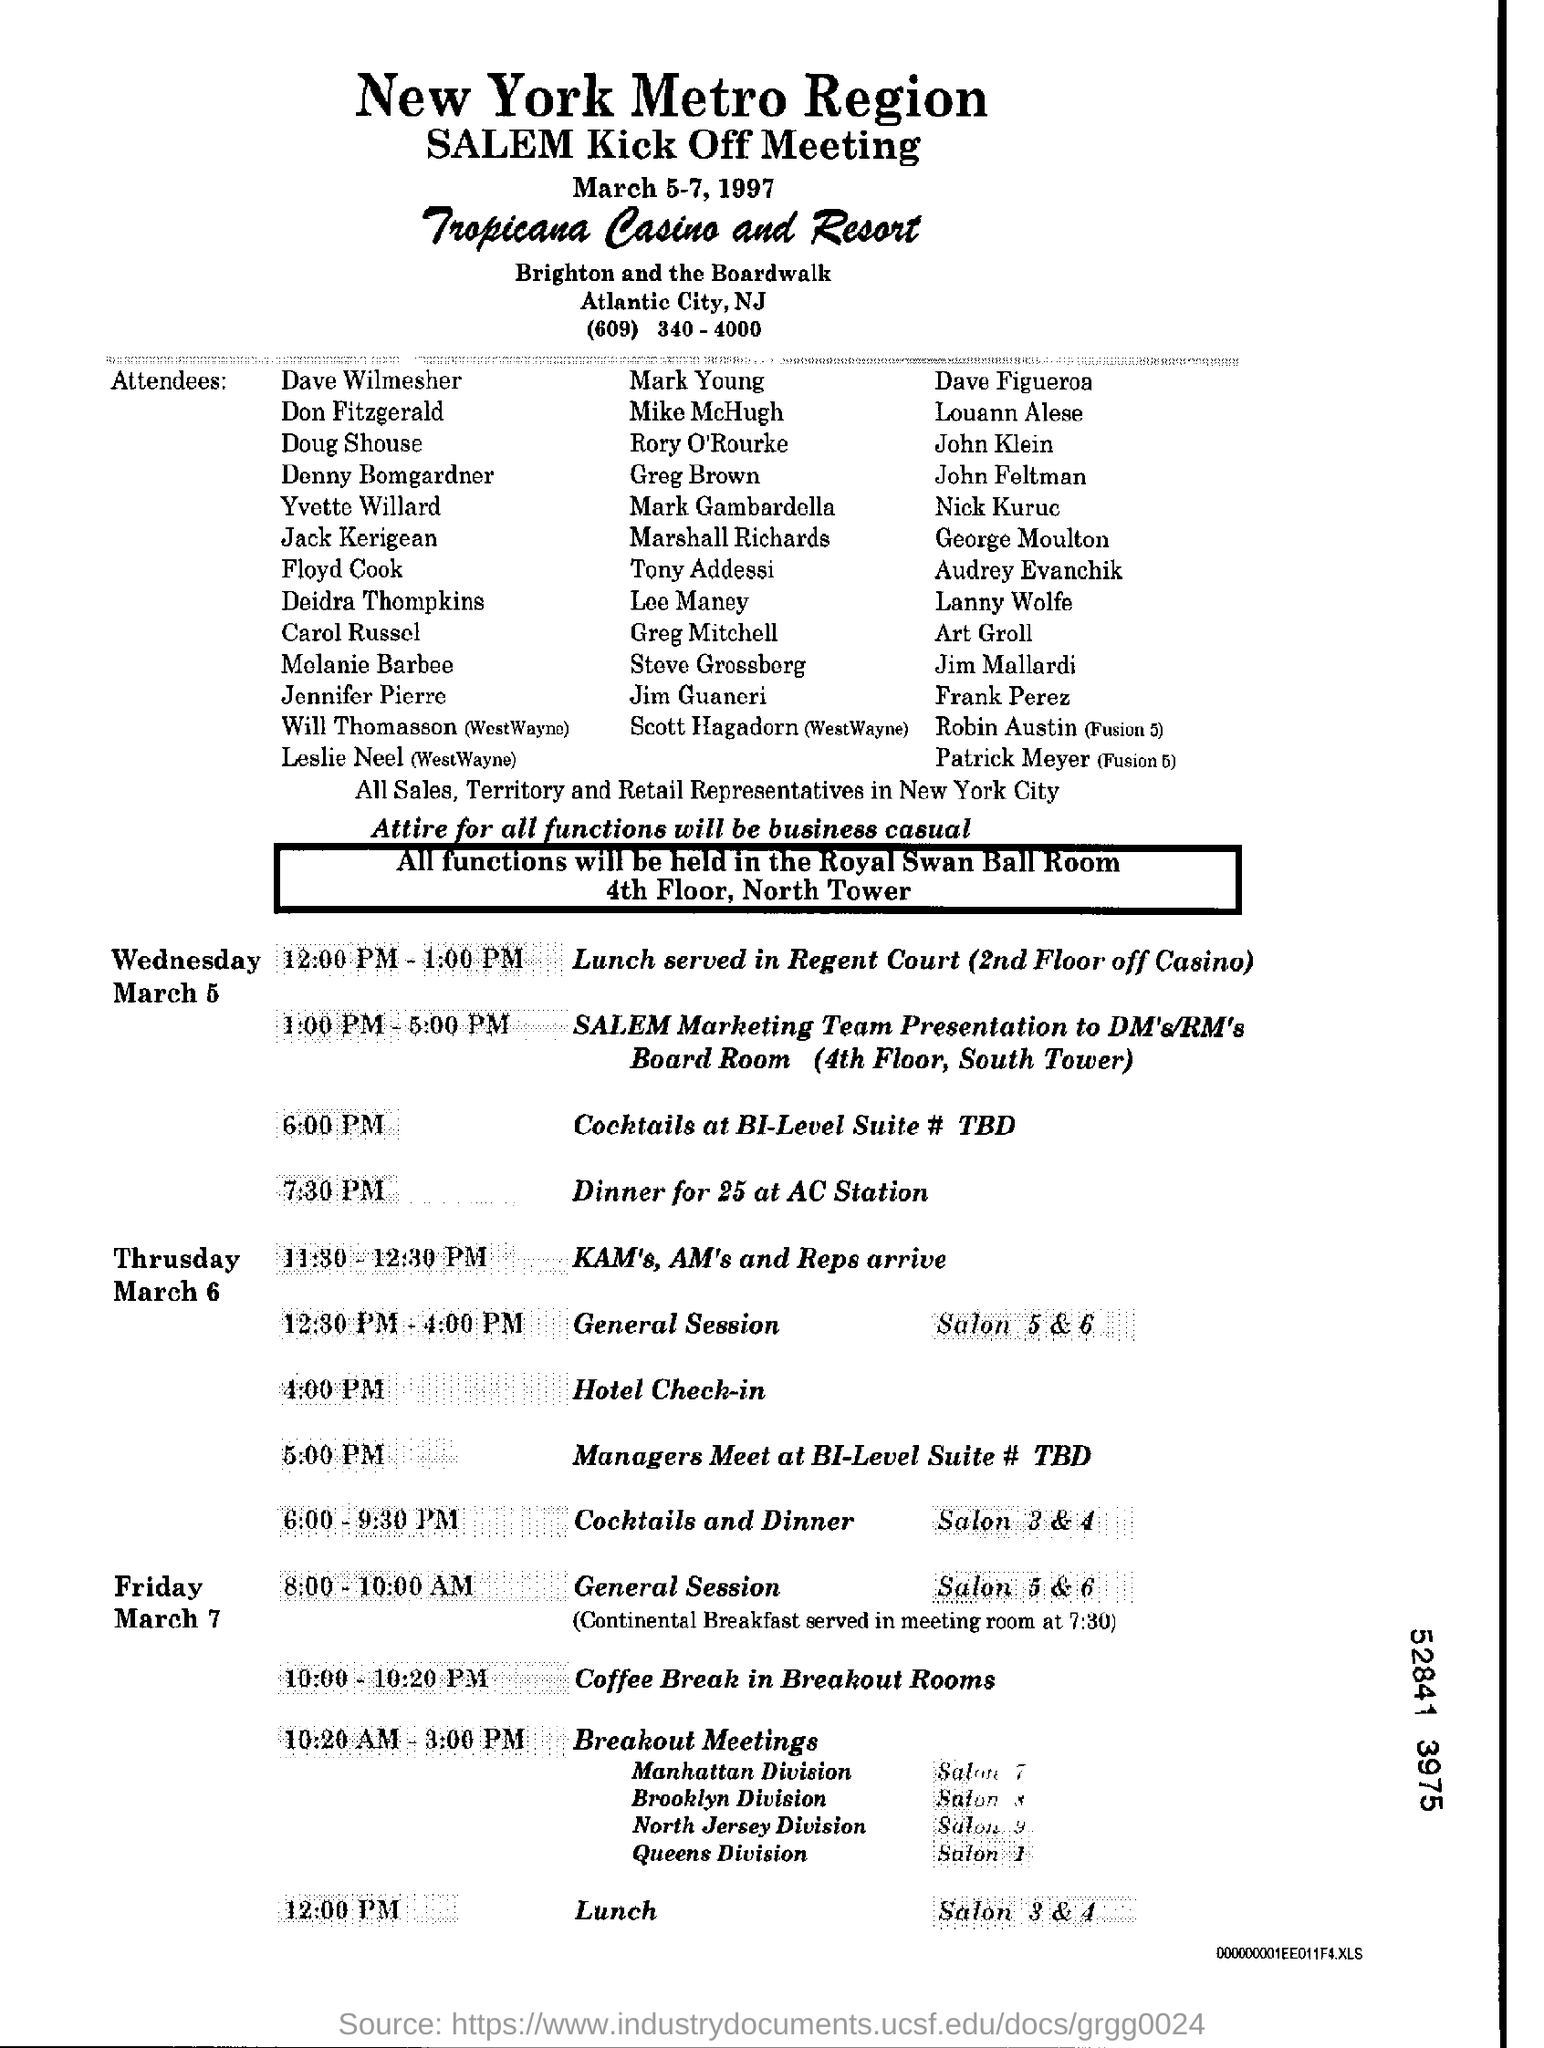Mention a couple of crucial points in this snapshot. The date indicated at the beginning of the document is March 5-7, 1997. On Friday at 12:00 PM, lunch time will occur. 